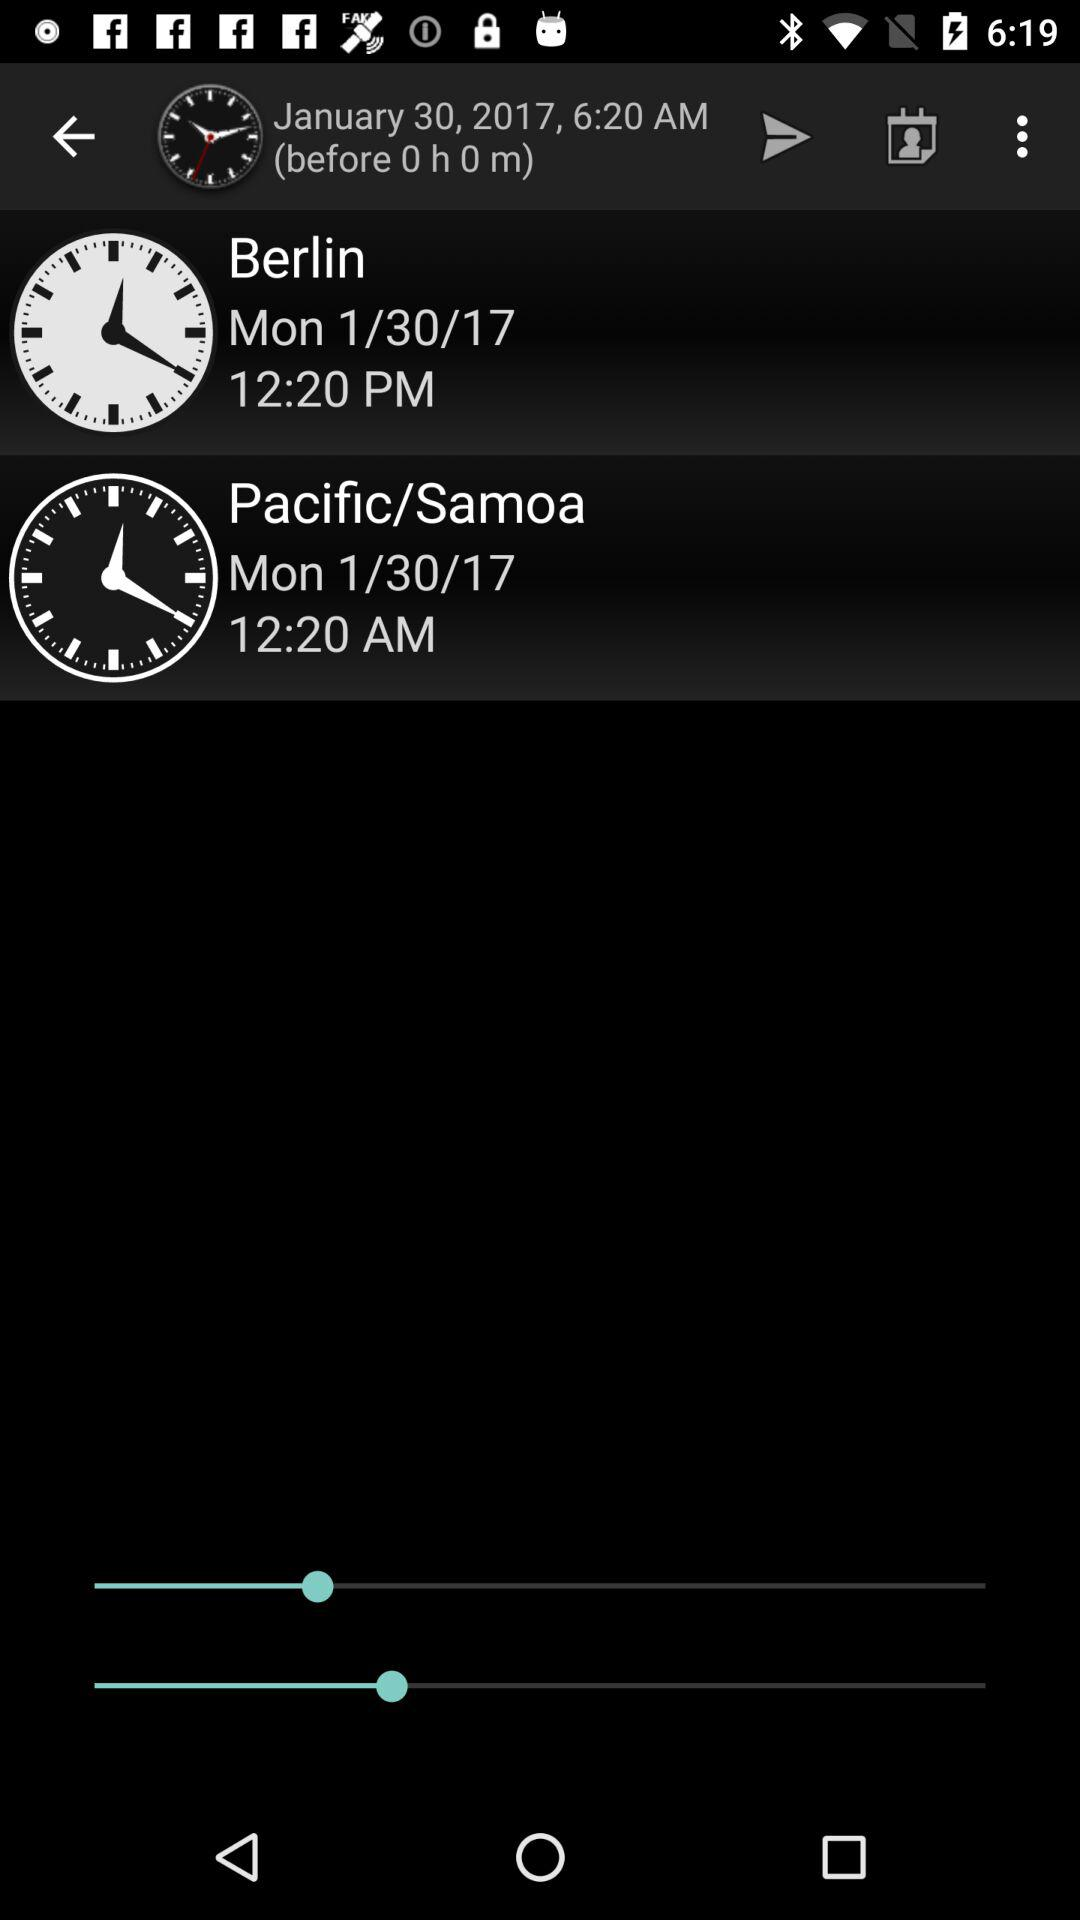What time is it in the Pacific/Samoa? The time in the Pacific/Samoa is 12:20 AM. 